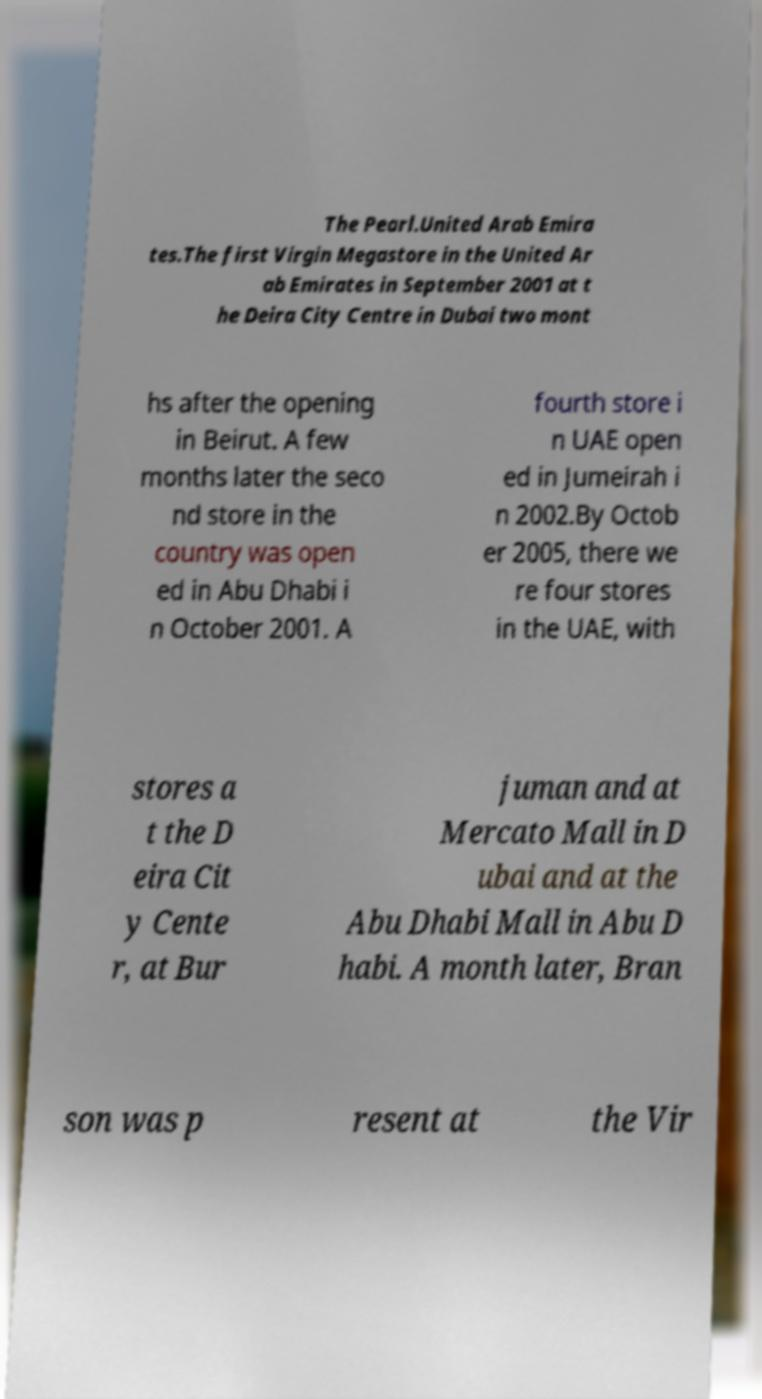I need the written content from this picture converted into text. Can you do that? The Pearl.United Arab Emira tes.The first Virgin Megastore in the United Ar ab Emirates in September 2001 at t he Deira City Centre in Dubai two mont hs after the opening in Beirut. A few months later the seco nd store in the country was open ed in Abu Dhabi i n October 2001. A fourth store i n UAE open ed in Jumeirah i n 2002.By Octob er 2005, there we re four stores in the UAE, with stores a t the D eira Cit y Cente r, at Bur juman and at Mercato Mall in D ubai and at the Abu Dhabi Mall in Abu D habi. A month later, Bran son was p resent at the Vir 